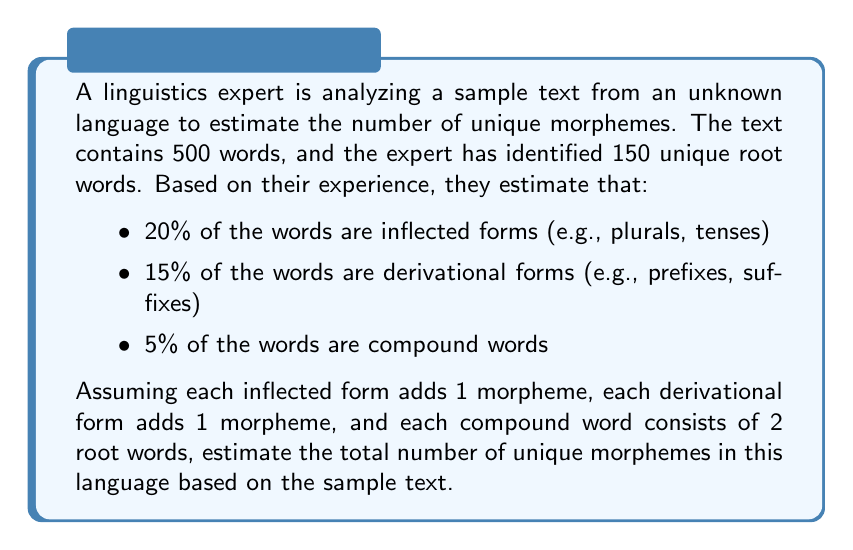Could you help me with this problem? Let's break this down step by step:

1) First, let's calculate the number of words in each category:
   - Inflected forms: $500 \times 0.20 = 100$ words
   - Derivational forms: $500 \times 0.15 = 75$ words
   - Compound words: $500 \times 0.05 = 25$ words
   - Remaining uninflected root words: $500 - (100 + 75 + 25) = 300$ words

2) Now, let's count the morphemes:
   - Root words: We start with 150 unique root words
   - Inflected forms: Each adds 1 morpheme, so $100 \times 1 = 100$ new morphemes
   - Derivational forms: Each adds 1 morpheme, so $75 \times 1 = 75$ new morphemes
   - Compound words: Each consists of 2 root words, but these are already counted in the root words, so they don't add new morphemes

3) Calculate the total:
   $$ \text{Total morphemes} = 150 + 100 + 75 = 325 $$

Therefore, based on this sample text, we estimate that the language has approximately 325 unique morphemes.

Note: This is a conservative estimate. In reality, a language likely has many more morphemes than what can be observed in a 500-word sample. The actual number would depend on the complexity of the language and how representative the sample is of the entire language.
Answer: The estimated number of unique morphemes in the language based on the sample text is 325. 